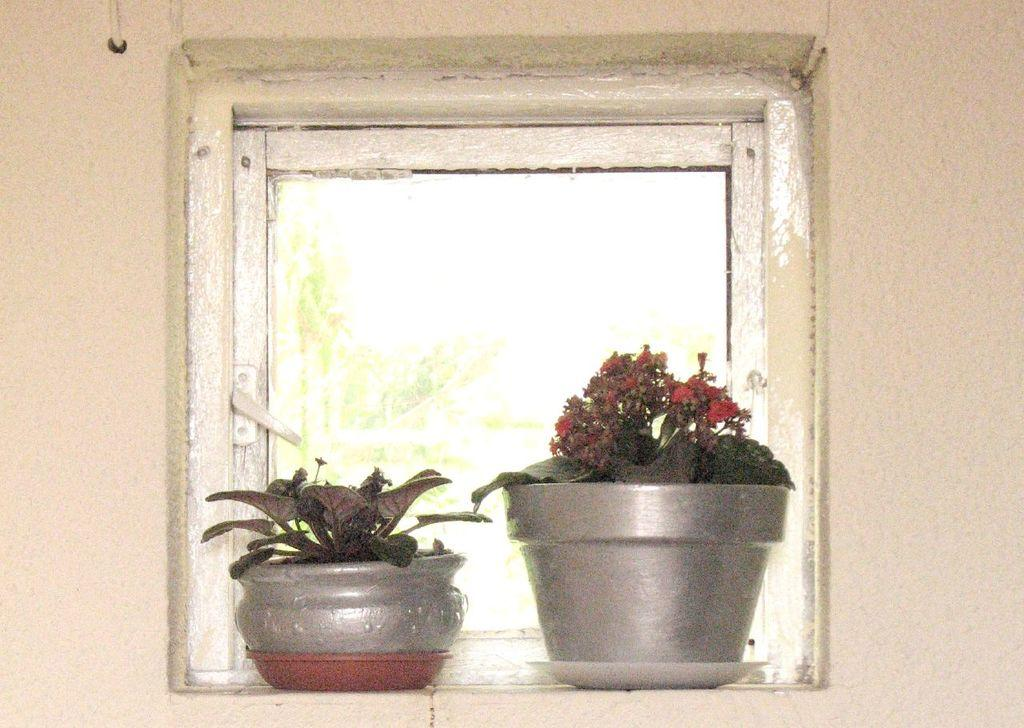What type of plants are in the image? There are plants in the pots in the image. How are the plants arranged or placed? The plants are kept in plates. Where are the plates with plants located? The plates with plants are placed beside a window. What can be seen on the other side of the window? The image does not show what is on the other side of the window. What is visible on the wall in the image? There is a wall visible in the image, but no specific details about the wall are provided. What type of crime is being committed in the image? There is no indication of any crime being committed in the image; it features plants in pots placed in plates beside a window. 